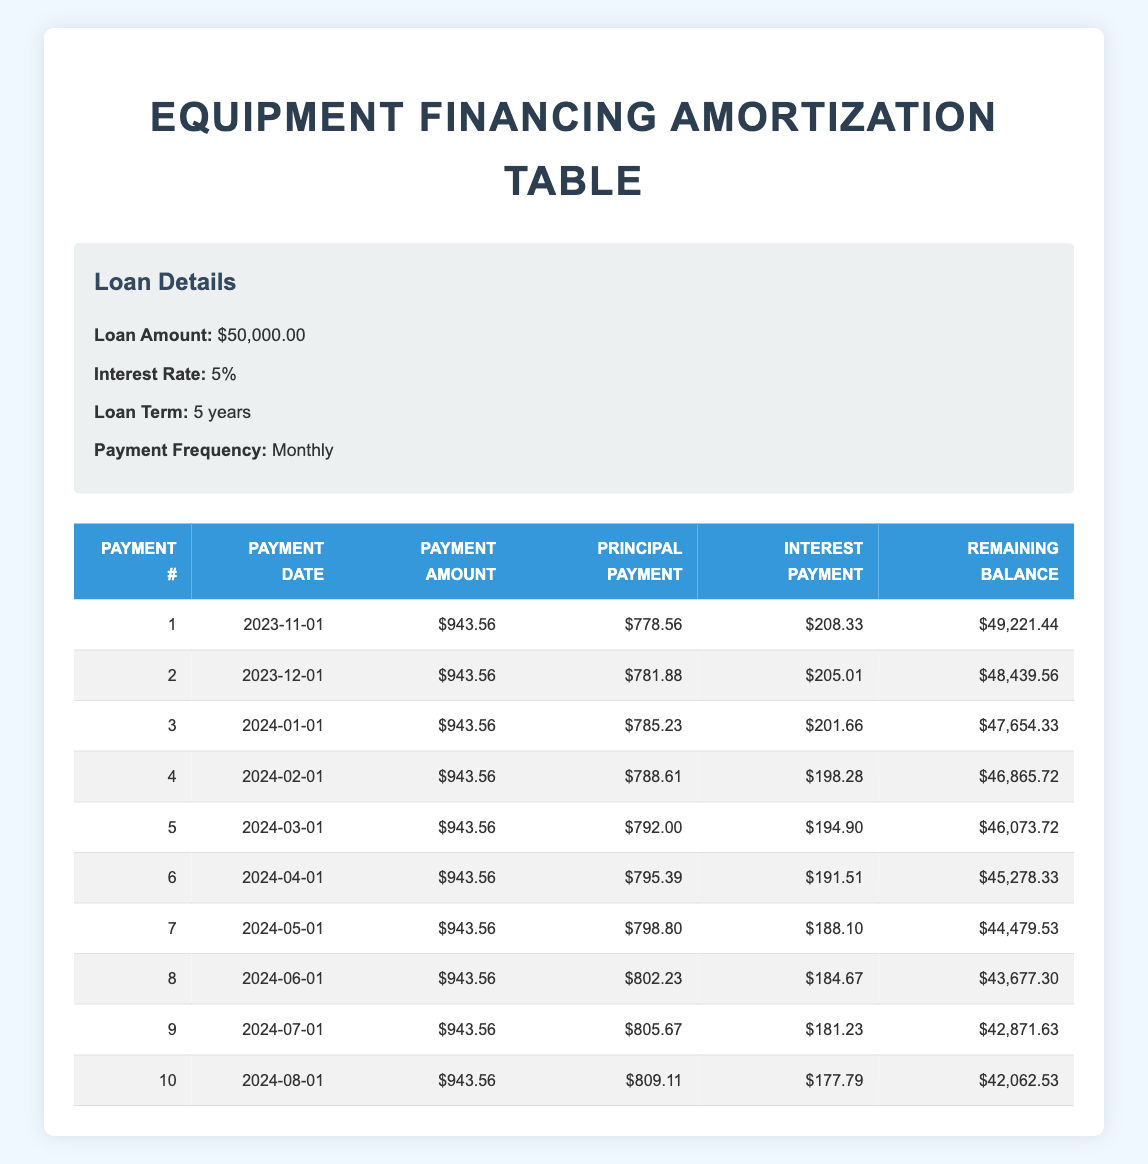What is the total payment amount over the first 10 months? Each monthly payment is 943.56, and there are 10 payments in total. Therefore, the total payment amount is calculated as 943.56 multiplied by 10, which is 9435.60.
Answer: 9435.60 How much interest will be paid in the first month? The interest payment for the first month is explicitly provided in the table, showing an interest payment of 208.33.
Answer: 208.33 What is the remaining balance after the second payment? The table states that after the second payment (payment number 2), the remaining balance is 48439.56.
Answer: 48439.56 Does the principal payment increase each month? Observing the principal payments from the first to the second month: 778.56 in the first month and 781.88 in the second month indicates an increase; looking through the subsequent months confirms this trend, thus the answer is yes.
Answer: Yes What is the average principal payment over the first 10 payments? To find the average, sum the principal payments from the first to the tenth payment (adding 778.56, 781.88, 785.23, 788.61, 792.00, 795.39, 798.80, 802.23, 805.67, and 809.11) and then divide by the number of payments (10). This results in a total of 7,633.58 divided by 10, giving an average of 763.36.
Answer: 763.36 What is the change in remaining balance from the first month to the second month? The remaining balance after the first month is 49221.44, and after the second month, it is 48439.56. The change is calculated by subtracting the second month balance from the first month balance, thus 49221.44 minus 48439.56 equals 781.88.
Answer: 781.88 Which payment has the highest principal payment, and what is the value? To find the highest principal payment, we compare all principal payments in the table. The tenth payment shows a principal amount of 809.11, which is higher than all previous payments.
Answer: 809.11 What is the total interest paid after the first five payments? For the first five payments, the interest payments were: 208.33 (1st), 205.01 (2nd), 201.66 (3rd), 198.28 (4th), and 194.90 (5th). Adding these amounts (208.33 + 205.01 + 201.66 + 198.28 + 194.90) gives a total interest paid of 1008.18.
Answer: 1008.18 What is the remaining balance after 10 payments? The table specifically states the remaining balance after the tenth payment as 42062.53. Thus, this information can be taken directly from the provided data.
Answer: 42062.53 